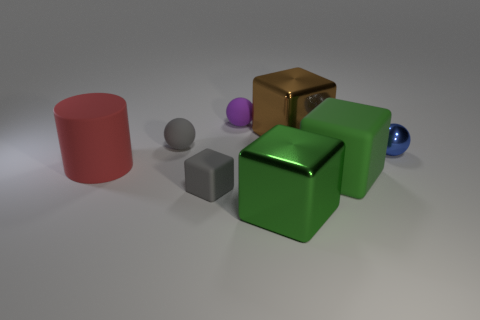Subtract all gray rubber spheres. How many spheres are left? 2 Add 1 tiny yellow matte things. How many objects exist? 9 Subtract all blue spheres. How many spheres are left? 2 Subtract all spheres. How many objects are left? 5 Subtract 3 balls. How many balls are left? 0 Subtract all blue balls. Subtract all yellow cubes. How many balls are left? 2 Subtract all blue cylinders. How many gray balls are left? 1 Subtract all purple spheres. Subtract all tiny things. How many objects are left? 3 Add 7 blue metal objects. How many blue metal objects are left? 8 Add 7 tiny rubber spheres. How many tiny rubber spheres exist? 9 